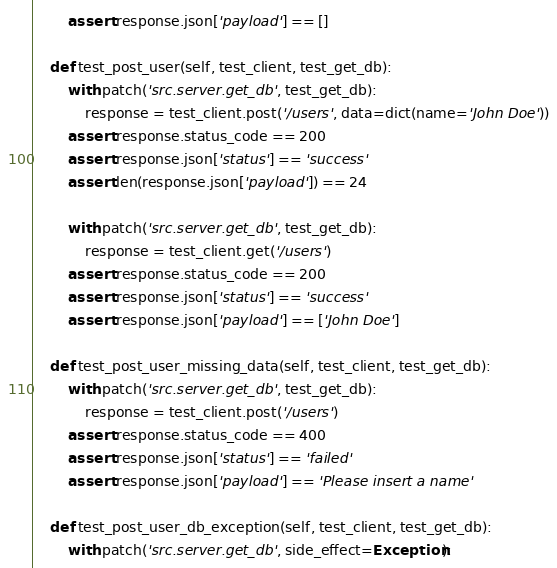Convert code to text. <code><loc_0><loc_0><loc_500><loc_500><_Python_>        assert response.json['payload'] == []

    def test_post_user(self, test_client, test_get_db):
        with patch('src.server.get_db', test_get_db):
            response = test_client.post('/users', data=dict(name='John Doe'))
        assert response.status_code == 200
        assert response.json['status'] == 'success'
        assert len(response.json['payload']) == 24

        with patch('src.server.get_db', test_get_db):
            response = test_client.get('/users')
        assert response.status_code == 200
        assert response.json['status'] == 'success'
        assert response.json['payload'] == ['John Doe']

    def test_post_user_missing_data(self, test_client, test_get_db):
        with patch('src.server.get_db', test_get_db):
            response = test_client.post('/users')
        assert response.status_code == 400
        assert response.json['status'] == 'failed'
        assert response.json['payload'] == 'Please insert a name'

    def test_post_user_db_exception(self, test_client, test_get_db):
        with patch('src.server.get_db', side_effect=Exception):</code> 